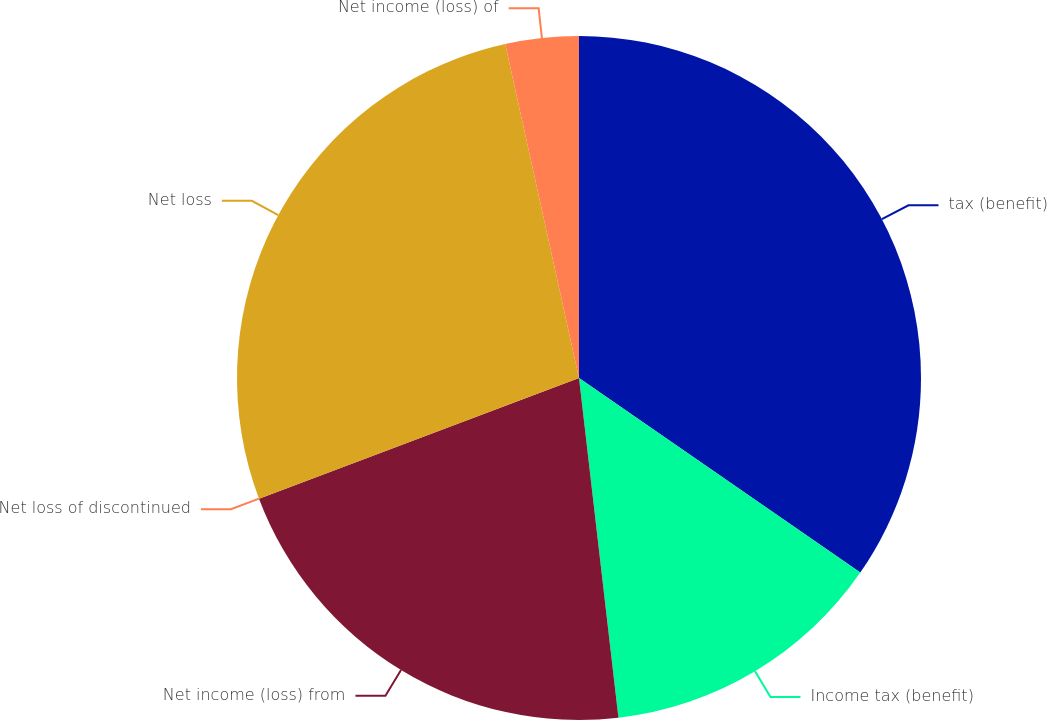Convert chart to OTSL. <chart><loc_0><loc_0><loc_500><loc_500><pie_chart><fcel>tax (benefit)<fcel>Income tax (benefit)<fcel>Net income (loss) from<fcel>Net loss of discontinued<fcel>Net loss<fcel>Net income (loss) of<nl><fcel>34.63%<fcel>13.53%<fcel>21.1%<fcel>0.0%<fcel>27.28%<fcel>3.46%<nl></chart> 